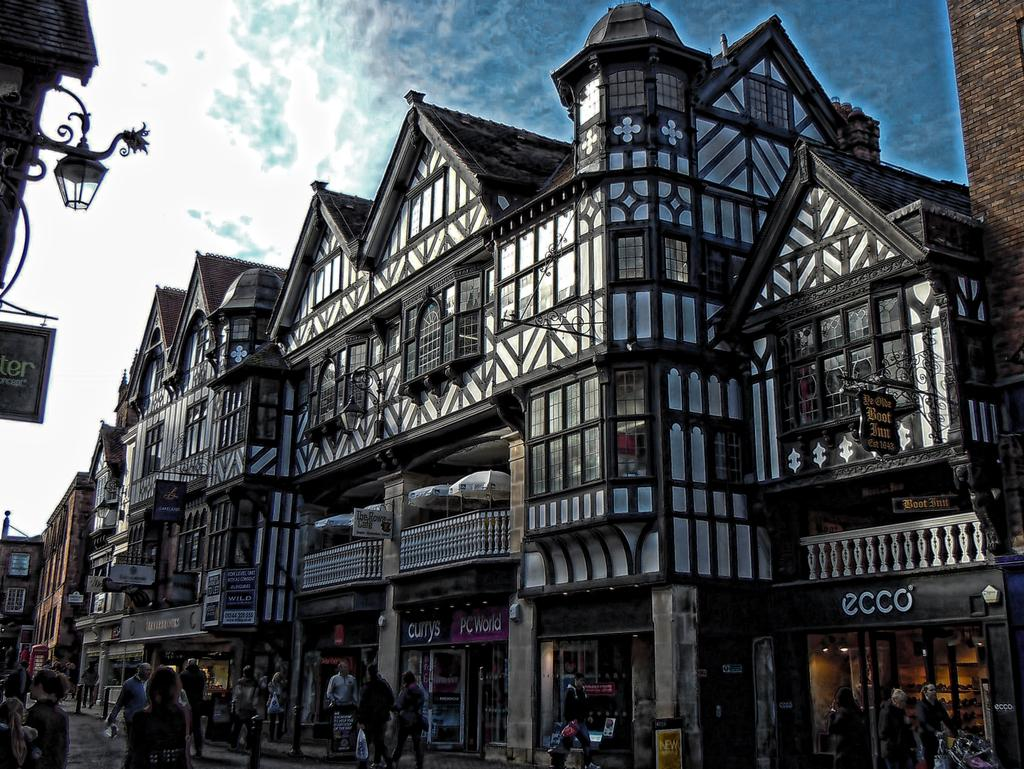What type of structures can be seen in the image? There are buildings in the image. What is happening on the road in the image? People are moving on the road in the image. How would you describe the sky in the image? The sky is clear with some clouds. Can you see any jellyfish swimming in the sky in the image? No, there are no jellyfish present in the image. Jellyfish are marine creatures and not found in the sky. 